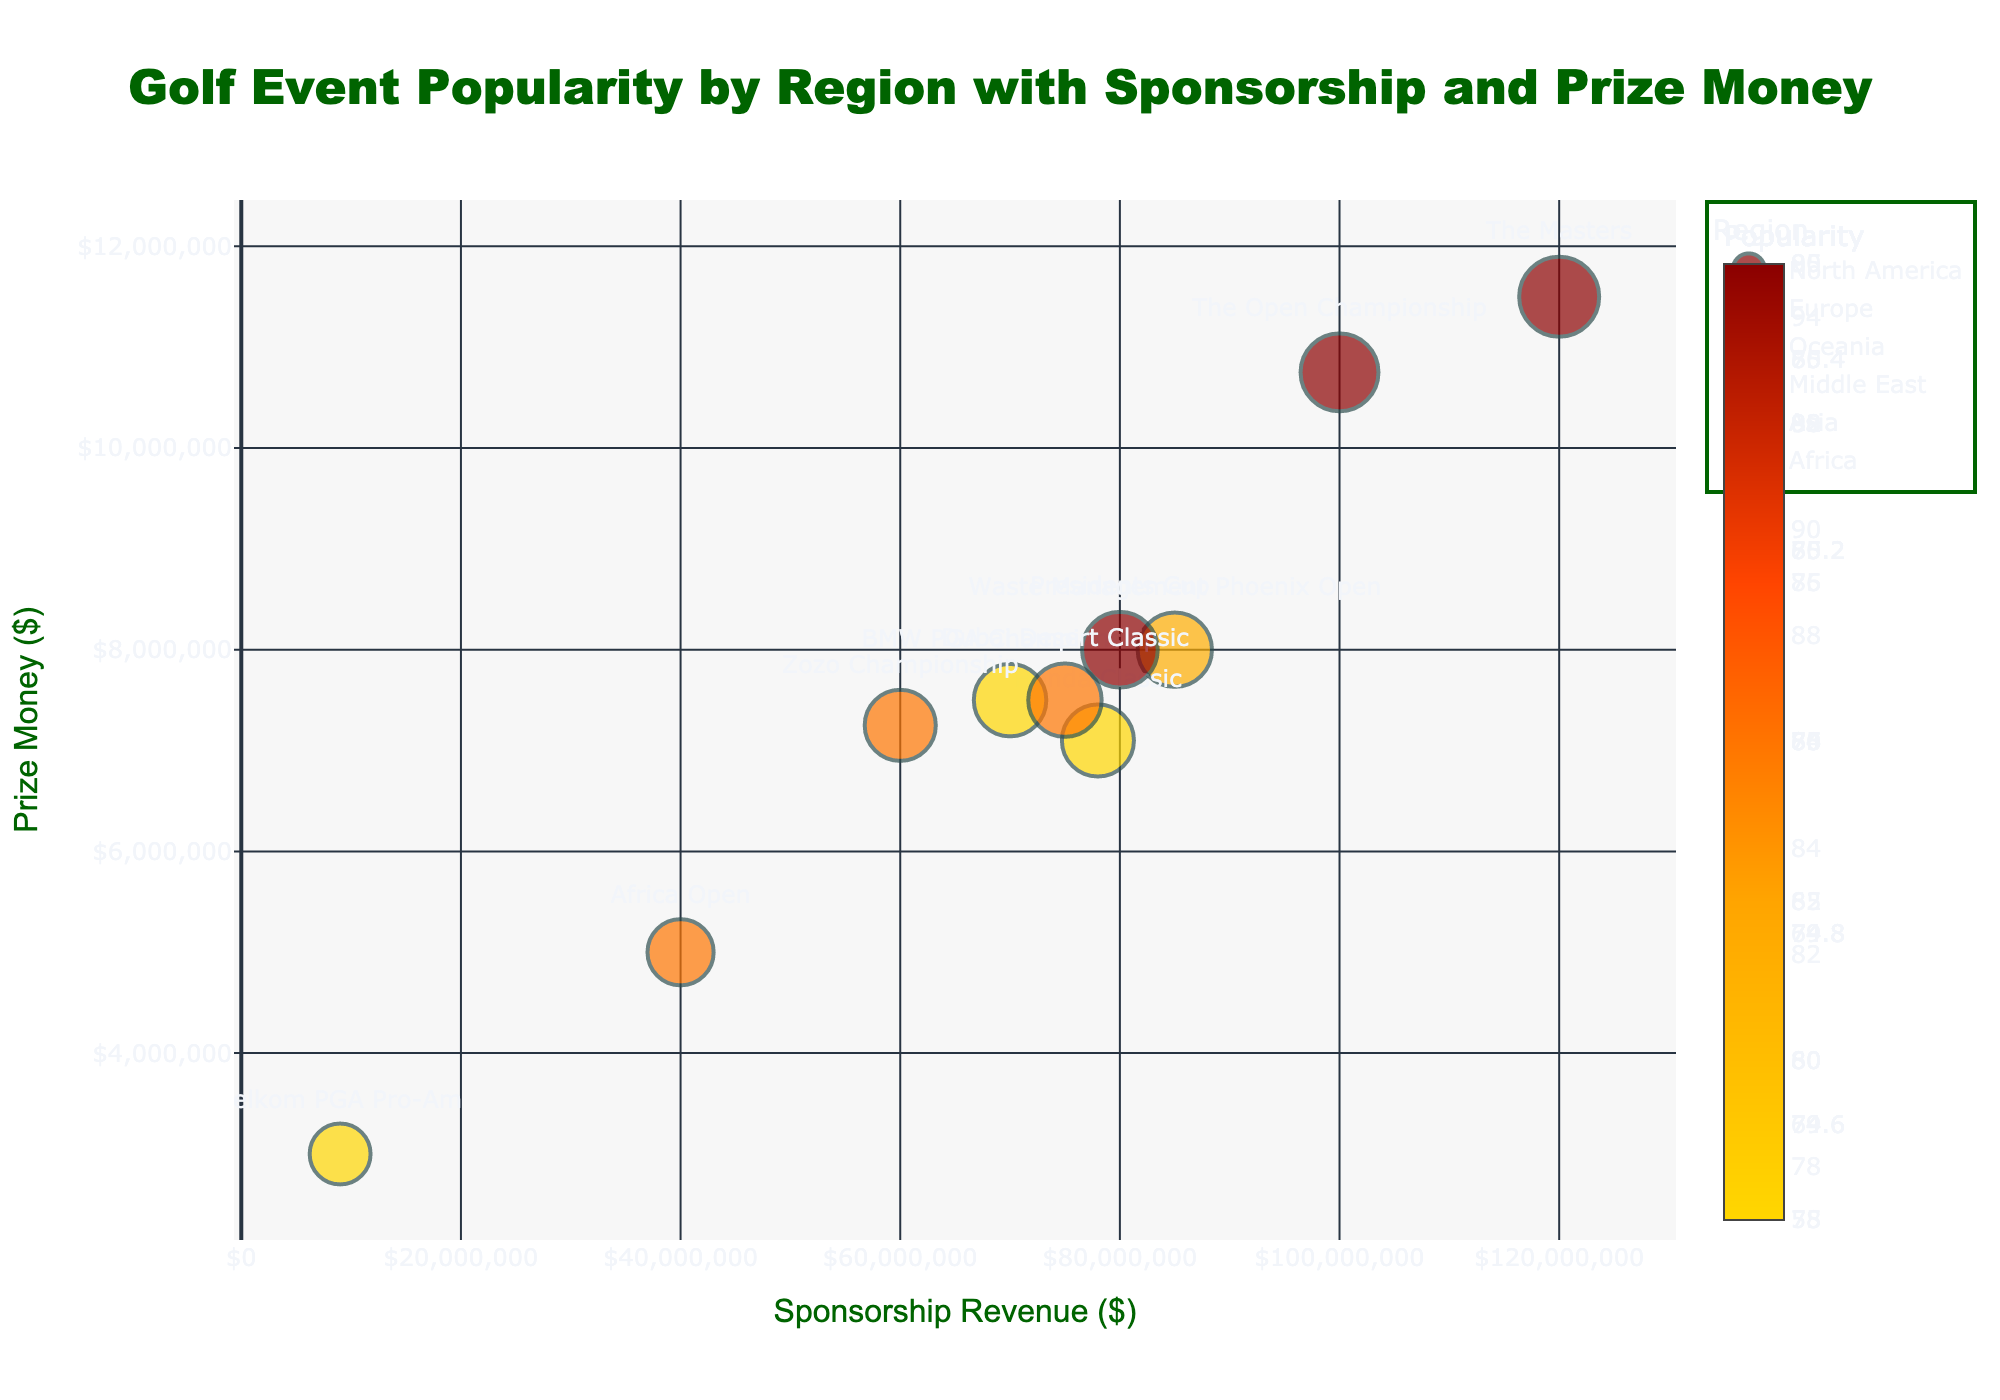What is the title of the chart? The title is located at the top of the figure and summarizes the main content depicted by the chart.
Answer: Golf Event Popularity by Region with Sponsorship and Prize Money Which region has the most events displayed in the chart? By counting the number of bubbles (data points) and their corresponding region labels, we can identify the region with the most events.
Answer: North America What is the Sponsorship Revenue and Prize Money for 'The Masters' event? Locate 'The Masters' bubble on the chart and read the x-axis for Sponsorship Revenue and y-axis for Prize Money.
Answer: $120,000,000 and $11,500,000 Which event has the highest popularity and what is its value? The size of bubbles represents popularity; hence, the largest bubble indicates the highest popularity. 'The Masters' has the largest bubble.
Answer: 95 Which region has the event with the highest Prize Money? Compare the y-axis values (Prize Money) across all regions and identify the highest value and its corresponding region. 'The Masters' in North America has the highest Prize Money.
Answer: North America What is the total Sponsorship Revenue for events in Europe? Sum the Sponsorship Revenue values of 'The Open Championship' and 'BMW PGA Championship' (Europe region).
Answer: 100,000,000 + 70,000,000 = 170,000,000 How does ‘The Open Championship’ compare in popularity to ‘Presidents Cup’? Compare the size of the bubbles for 'The Open Championship' and 'Presidents Cup'. 'The Open Championship' has a slightly larger bubble.
Answer: 'The Open Championship' is more popular How many events have a popularity greater than 80? Count the number of bubbles with sizes indicating popularity greater than 80.
Answer: Five events (The Masters, The Open Championship, Presidents Cup, Waste Management Phoenix Open, Dubai Desert Classic) Which event in Asia has the lowest Prize Money? Find the bubbles with the Asian region and compare their Prize Money values. 'Zozo Championship' is the only event, so it has the lowest.
Answer: Zozo Championship What's the average Prize Money for North American events? Sum the Prize Money values for all North American events and divide by the number of these events. (11,500,000 + 8,000,000 + 7,100,000) / 3
Answer: (26,600,000 / 3) = 8,866,667 